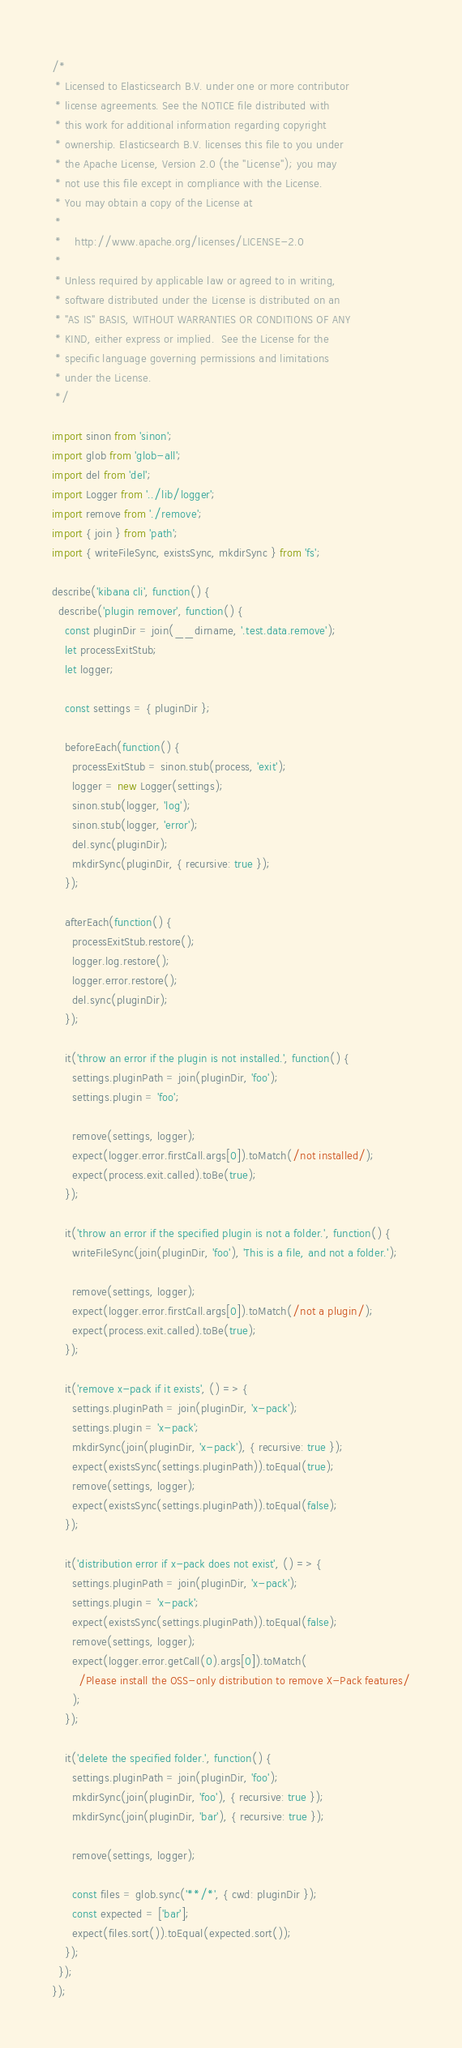Convert code to text. <code><loc_0><loc_0><loc_500><loc_500><_JavaScript_>/*
 * Licensed to Elasticsearch B.V. under one or more contributor
 * license agreements. See the NOTICE file distributed with
 * this work for additional information regarding copyright
 * ownership. Elasticsearch B.V. licenses this file to you under
 * the Apache License, Version 2.0 (the "License"); you may
 * not use this file except in compliance with the License.
 * You may obtain a copy of the License at
 *
 *    http://www.apache.org/licenses/LICENSE-2.0
 *
 * Unless required by applicable law or agreed to in writing,
 * software distributed under the License is distributed on an
 * "AS IS" BASIS, WITHOUT WARRANTIES OR CONDITIONS OF ANY
 * KIND, either express or implied.  See the License for the
 * specific language governing permissions and limitations
 * under the License.
 */

import sinon from 'sinon';
import glob from 'glob-all';
import del from 'del';
import Logger from '../lib/logger';
import remove from './remove';
import { join } from 'path';
import { writeFileSync, existsSync, mkdirSync } from 'fs';

describe('kibana cli', function() {
  describe('plugin remover', function() {
    const pluginDir = join(__dirname, '.test.data.remove');
    let processExitStub;
    let logger;

    const settings = { pluginDir };

    beforeEach(function() {
      processExitStub = sinon.stub(process, 'exit');
      logger = new Logger(settings);
      sinon.stub(logger, 'log');
      sinon.stub(logger, 'error');
      del.sync(pluginDir);
      mkdirSync(pluginDir, { recursive: true });
    });

    afterEach(function() {
      processExitStub.restore();
      logger.log.restore();
      logger.error.restore();
      del.sync(pluginDir);
    });

    it('throw an error if the plugin is not installed.', function() {
      settings.pluginPath = join(pluginDir, 'foo');
      settings.plugin = 'foo';

      remove(settings, logger);
      expect(logger.error.firstCall.args[0]).toMatch(/not installed/);
      expect(process.exit.called).toBe(true);
    });

    it('throw an error if the specified plugin is not a folder.', function() {
      writeFileSync(join(pluginDir, 'foo'), 'This is a file, and not a folder.');

      remove(settings, logger);
      expect(logger.error.firstCall.args[0]).toMatch(/not a plugin/);
      expect(process.exit.called).toBe(true);
    });

    it('remove x-pack if it exists', () => {
      settings.pluginPath = join(pluginDir, 'x-pack');
      settings.plugin = 'x-pack';
      mkdirSync(join(pluginDir, 'x-pack'), { recursive: true });
      expect(existsSync(settings.pluginPath)).toEqual(true);
      remove(settings, logger);
      expect(existsSync(settings.pluginPath)).toEqual(false);
    });

    it('distribution error if x-pack does not exist', () => {
      settings.pluginPath = join(pluginDir, 'x-pack');
      settings.plugin = 'x-pack';
      expect(existsSync(settings.pluginPath)).toEqual(false);
      remove(settings, logger);
      expect(logger.error.getCall(0).args[0]).toMatch(
        /Please install the OSS-only distribution to remove X-Pack features/
      );
    });

    it('delete the specified folder.', function() {
      settings.pluginPath = join(pluginDir, 'foo');
      mkdirSync(join(pluginDir, 'foo'), { recursive: true });
      mkdirSync(join(pluginDir, 'bar'), { recursive: true });

      remove(settings, logger);

      const files = glob.sync('**/*', { cwd: pluginDir });
      const expected = ['bar'];
      expect(files.sort()).toEqual(expected.sort());
    });
  });
});
</code> 